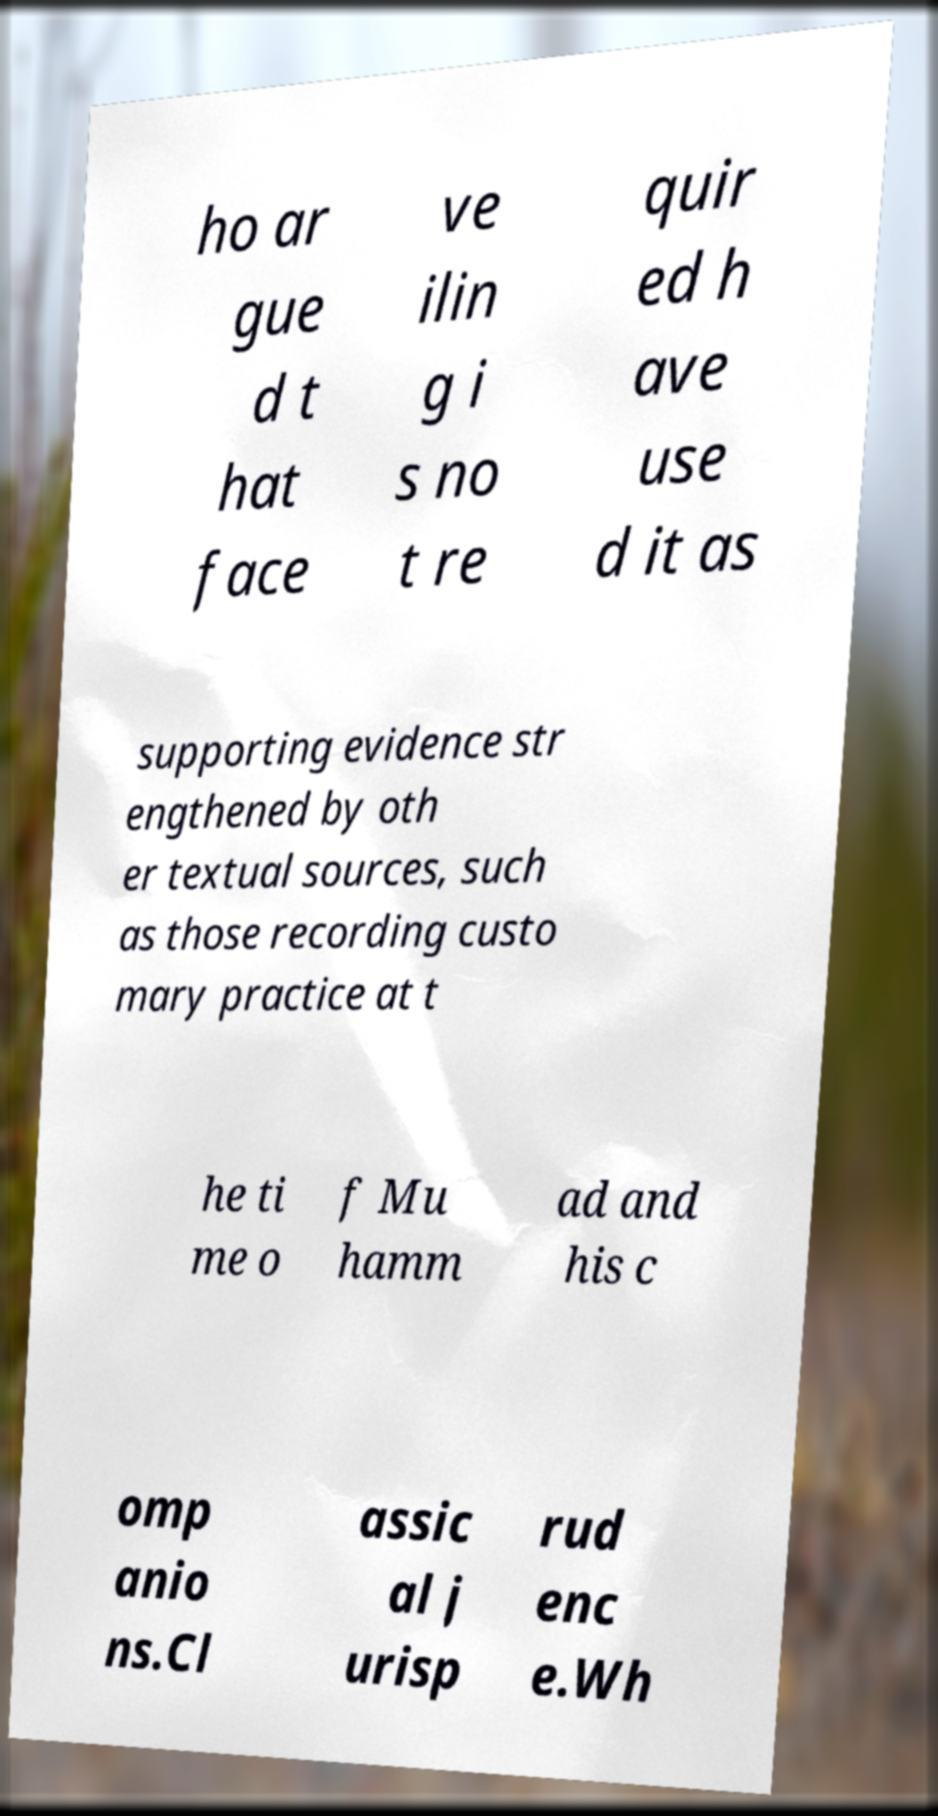Could you extract and type out the text from this image? ho ar gue d t hat face ve ilin g i s no t re quir ed h ave use d it as supporting evidence str engthened by oth er textual sources, such as those recording custo mary practice at t he ti me o f Mu hamm ad and his c omp anio ns.Cl assic al j urisp rud enc e.Wh 